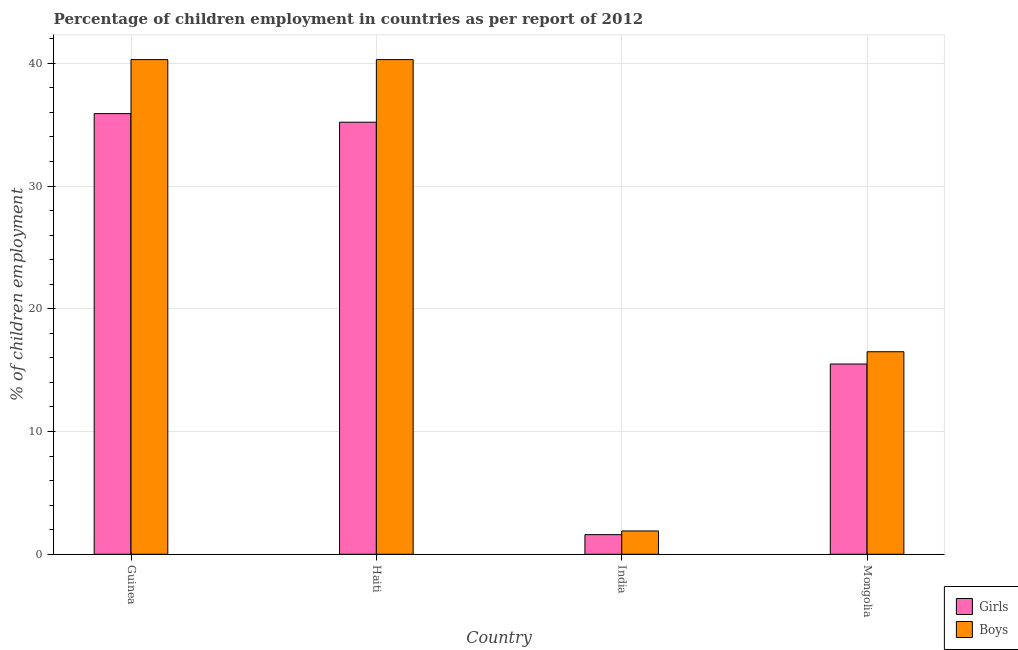Are the number of bars on each tick of the X-axis equal?
Make the answer very short. Yes. How many bars are there on the 1st tick from the right?
Make the answer very short. 2. What is the label of the 3rd group of bars from the left?
Offer a very short reply. India. In how many cases, is the number of bars for a given country not equal to the number of legend labels?
Provide a short and direct response. 0. What is the percentage of employed boys in Guinea?
Provide a succinct answer. 40.3. Across all countries, what is the maximum percentage of employed girls?
Give a very brief answer. 35.9. Across all countries, what is the minimum percentage of employed boys?
Make the answer very short. 1.9. In which country was the percentage of employed boys maximum?
Offer a very short reply. Guinea. What is the total percentage of employed boys in the graph?
Make the answer very short. 99. What is the difference between the percentage of employed girls in Guinea and that in Haiti?
Provide a short and direct response. 0.7. What is the difference between the percentage of employed girls in Haiti and the percentage of employed boys in Mongolia?
Provide a short and direct response. 18.7. What is the average percentage of employed boys per country?
Give a very brief answer. 24.75. What is the difference between the percentage of employed girls and percentage of employed boys in Guinea?
Your answer should be compact. -4.4. What is the ratio of the percentage of employed boys in Haiti to that in Mongolia?
Your answer should be compact. 2.44. Is the percentage of employed boys in Guinea less than that in India?
Your answer should be compact. No. Is the difference between the percentage of employed boys in Guinea and Mongolia greater than the difference between the percentage of employed girls in Guinea and Mongolia?
Your response must be concise. Yes. What is the difference between the highest and the second highest percentage of employed girls?
Offer a terse response. 0.7. What is the difference between the highest and the lowest percentage of employed boys?
Ensure brevity in your answer.  38.4. Is the sum of the percentage of employed girls in Haiti and India greater than the maximum percentage of employed boys across all countries?
Ensure brevity in your answer.  No. What does the 1st bar from the left in Guinea represents?
Provide a short and direct response. Girls. What does the 1st bar from the right in India represents?
Ensure brevity in your answer.  Boys. Are all the bars in the graph horizontal?
Give a very brief answer. No. How many countries are there in the graph?
Ensure brevity in your answer.  4. What is the difference between two consecutive major ticks on the Y-axis?
Your answer should be compact. 10. Are the values on the major ticks of Y-axis written in scientific E-notation?
Give a very brief answer. No. Does the graph contain any zero values?
Ensure brevity in your answer.  No. Does the graph contain grids?
Keep it short and to the point. Yes. How are the legend labels stacked?
Your response must be concise. Vertical. What is the title of the graph?
Your answer should be compact. Percentage of children employment in countries as per report of 2012. What is the label or title of the X-axis?
Ensure brevity in your answer.  Country. What is the label or title of the Y-axis?
Your answer should be very brief. % of children employment. What is the % of children employment of Girls in Guinea?
Your answer should be very brief. 35.9. What is the % of children employment of Boys in Guinea?
Your answer should be compact. 40.3. What is the % of children employment in Girls in Haiti?
Offer a very short reply. 35.2. What is the % of children employment of Boys in Haiti?
Make the answer very short. 40.3. What is the % of children employment in Girls in India?
Ensure brevity in your answer.  1.6. What is the % of children employment of Boys in India?
Make the answer very short. 1.9. What is the % of children employment of Boys in Mongolia?
Ensure brevity in your answer.  16.5. Across all countries, what is the maximum % of children employment of Girls?
Provide a short and direct response. 35.9. Across all countries, what is the maximum % of children employment in Boys?
Your response must be concise. 40.3. Across all countries, what is the minimum % of children employment in Girls?
Ensure brevity in your answer.  1.6. What is the total % of children employment of Girls in the graph?
Provide a succinct answer. 88.2. What is the difference between the % of children employment of Boys in Guinea and that in Haiti?
Your answer should be very brief. 0. What is the difference between the % of children employment in Girls in Guinea and that in India?
Ensure brevity in your answer.  34.3. What is the difference between the % of children employment in Boys in Guinea and that in India?
Offer a very short reply. 38.4. What is the difference between the % of children employment of Girls in Guinea and that in Mongolia?
Your answer should be compact. 20.4. What is the difference between the % of children employment of Boys in Guinea and that in Mongolia?
Provide a short and direct response. 23.8. What is the difference between the % of children employment of Girls in Haiti and that in India?
Your answer should be compact. 33.6. What is the difference between the % of children employment of Boys in Haiti and that in India?
Provide a short and direct response. 38.4. What is the difference between the % of children employment in Girls in Haiti and that in Mongolia?
Your answer should be very brief. 19.7. What is the difference between the % of children employment in Boys in Haiti and that in Mongolia?
Your answer should be compact. 23.8. What is the difference between the % of children employment of Girls in India and that in Mongolia?
Provide a succinct answer. -13.9. What is the difference between the % of children employment of Boys in India and that in Mongolia?
Your answer should be very brief. -14.6. What is the difference between the % of children employment of Girls in Haiti and the % of children employment of Boys in India?
Give a very brief answer. 33.3. What is the difference between the % of children employment in Girls in India and the % of children employment in Boys in Mongolia?
Keep it short and to the point. -14.9. What is the average % of children employment in Girls per country?
Offer a terse response. 22.05. What is the average % of children employment in Boys per country?
Provide a short and direct response. 24.75. What is the difference between the % of children employment in Girls and % of children employment in Boys in Guinea?
Your answer should be very brief. -4.4. What is the difference between the % of children employment of Girls and % of children employment of Boys in Haiti?
Keep it short and to the point. -5.1. What is the difference between the % of children employment in Girls and % of children employment in Boys in India?
Provide a short and direct response. -0.3. What is the difference between the % of children employment in Girls and % of children employment in Boys in Mongolia?
Your response must be concise. -1. What is the ratio of the % of children employment in Girls in Guinea to that in Haiti?
Give a very brief answer. 1.02. What is the ratio of the % of children employment of Boys in Guinea to that in Haiti?
Provide a succinct answer. 1. What is the ratio of the % of children employment of Girls in Guinea to that in India?
Your response must be concise. 22.44. What is the ratio of the % of children employment of Boys in Guinea to that in India?
Provide a succinct answer. 21.21. What is the ratio of the % of children employment of Girls in Guinea to that in Mongolia?
Keep it short and to the point. 2.32. What is the ratio of the % of children employment of Boys in Guinea to that in Mongolia?
Offer a terse response. 2.44. What is the ratio of the % of children employment of Boys in Haiti to that in India?
Your response must be concise. 21.21. What is the ratio of the % of children employment of Girls in Haiti to that in Mongolia?
Offer a terse response. 2.27. What is the ratio of the % of children employment in Boys in Haiti to that in Mongolia?
Provide a short and direct response. 2.44. What is the ratio of the % of children employment of Girls in India to that in Mongolia?
Give a very brief answer. 0.1. What is the ratio of the % of children employment of Boys in India to that in Mongolia?
Your response must be concise. 0.12. What is the difference between the highest and the second highest % of children employment of Girls?
Give a very brief answer. 0.7. What is the difference between the highest and the lowest % of children employment of Girls?
Ensure brevity in your answer.  34.3. What is the difference between the highest and the lowest % of children employment of Boys?
Provide a succinct answer. 38.4. 